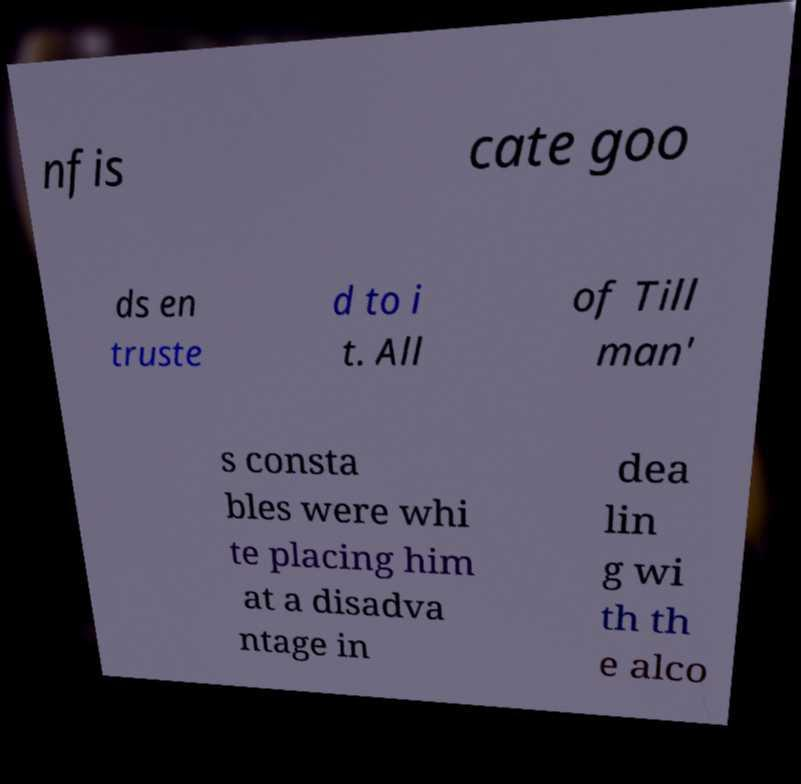Could you assist in decoding the text presented in this image and type it out clearly? nfis cate goo ds en truste d to i t. All of Till man' s consta bles were whi te placing him at a disadva ntage in dea lin g wi th th e alco 